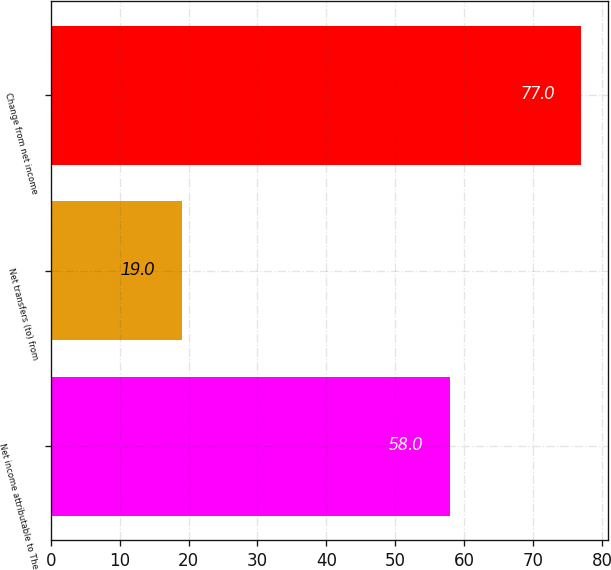Convert chart. <chart><loc_0><loc_0><loc_500><loc_500><bar_chart><fcel>Net income attributable to The<fcel>Net transfers (to) from<fcel>Change from net income<nl><fcel>58<fcel>19<fcel>77<nl></chart> 